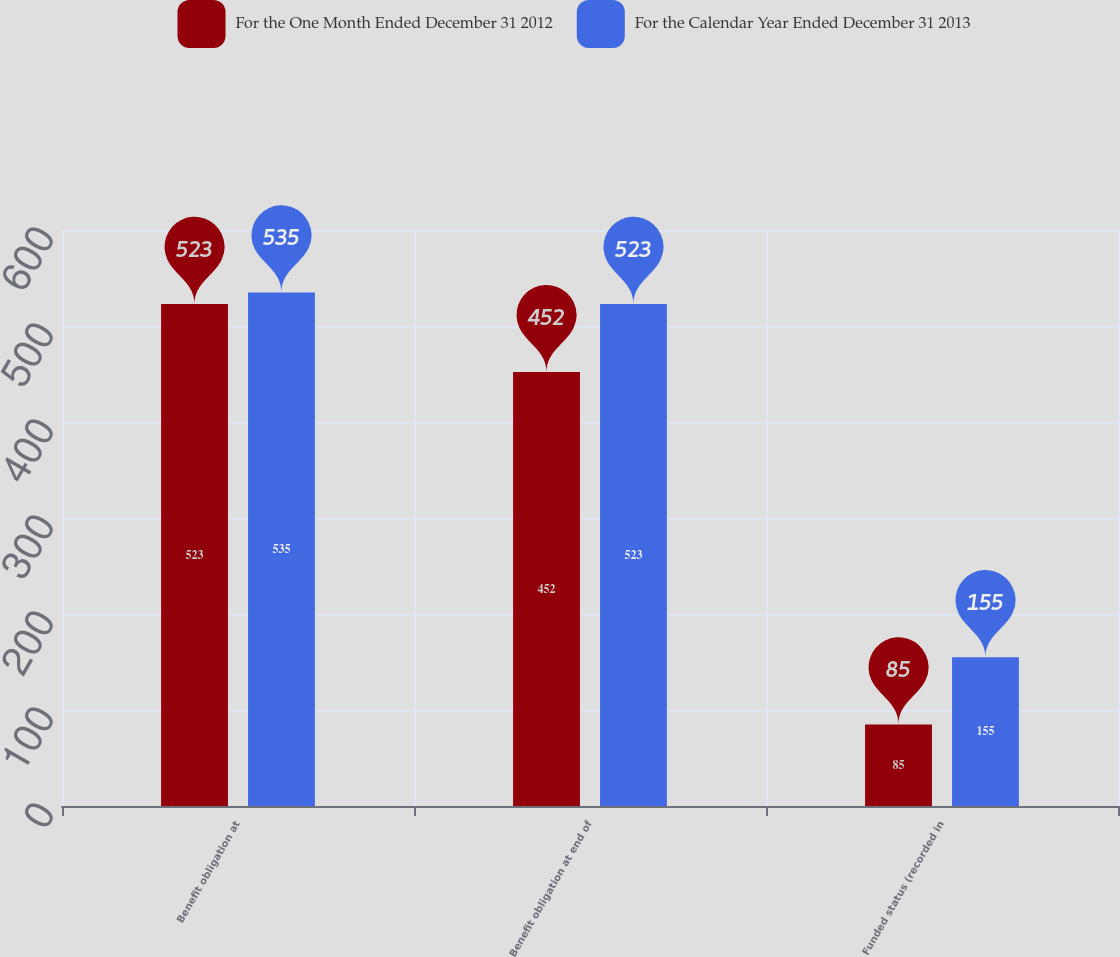Convert chart to OTSL. <chart><loc_0><loc_0><loc_500><loc_500><stacked_bar_chart><ecel><fcel>Benefit obligation at<fcel>Benefit obligation at end of<fcel>Funded status (recorded in<nl><fcel>For the One Month Ended December 31 2012<fcel>523<fcel>452<fcel>85<nl><fcel>For the Calendar Year Ended December 31 2013<fcel>535<fcel>523<fcel>155<nl></chart> 